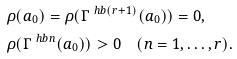<formula> <loc_0><loc_0><loc_500><loc_500>& \rho ( a _ { 0 } ) = \rho ( \Gamma ^ { \ h b ( r + 1 ) } ( a _ { 0 } ) ) = 0 , \\ & \rho ( \Gamma ^ { \ h b n } ( a _ { 0 } ) ) > 0 \quad ( n = 1 , \dots , r ) .</formula> 